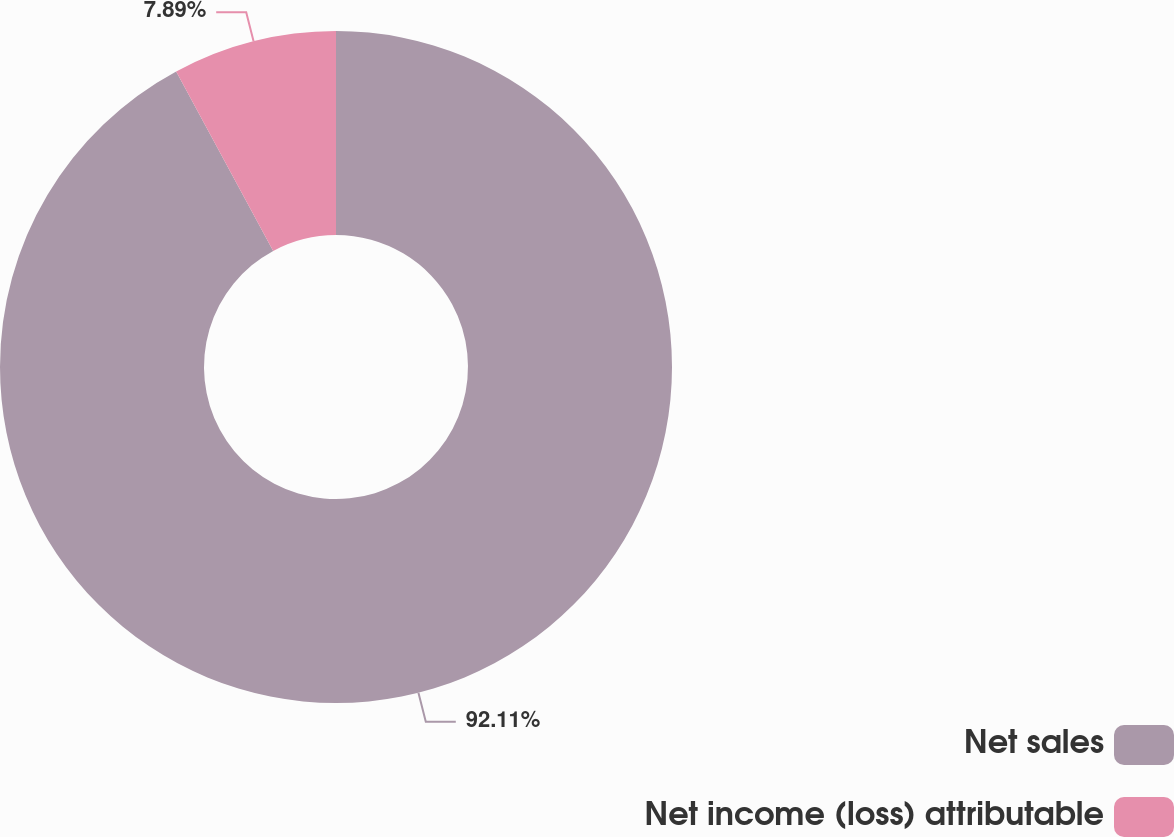Convert chart. <chart><loc_0><loc_0><loc_500><loc_500><pie_chart><fcel>Net sales<fcel>Net income (loss) attributable<nl><fcel>92.11%<fcel>7.89%<nl></chart> 